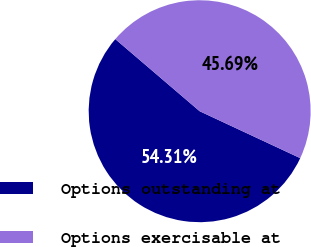<chart> <loc_0><loc_0><loc_500><loc_500><pie_chart><fcel>Options outstanding at<fcel>Options exercisable at<nl><fcel>54.31%<fcel>45.69%<nl></chart> 